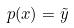Convert formula to latex. <formula><loc_0><loc_0><loc_500><loc_500>p ( x ) = \tilde { y }</formula> 